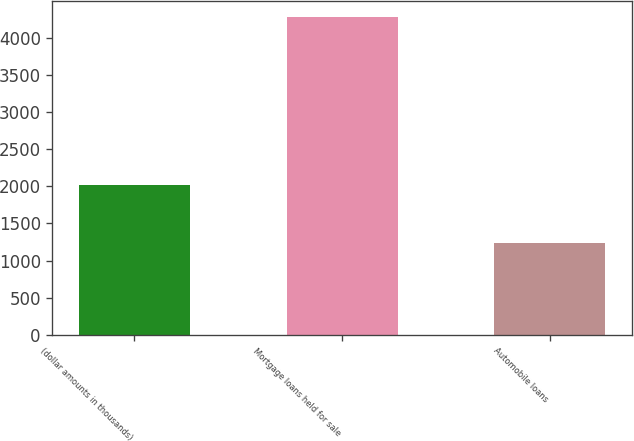<chart> <loc_0><loc_0><loc_500><loc_500><bar_chart><fcel>(dollar amounts in thousands)<fcel>Mortgage loans held for sale<fcel>Automobile loans<nl><fcel>2012<fcel>4284<fcel>1231<nl></chart> 